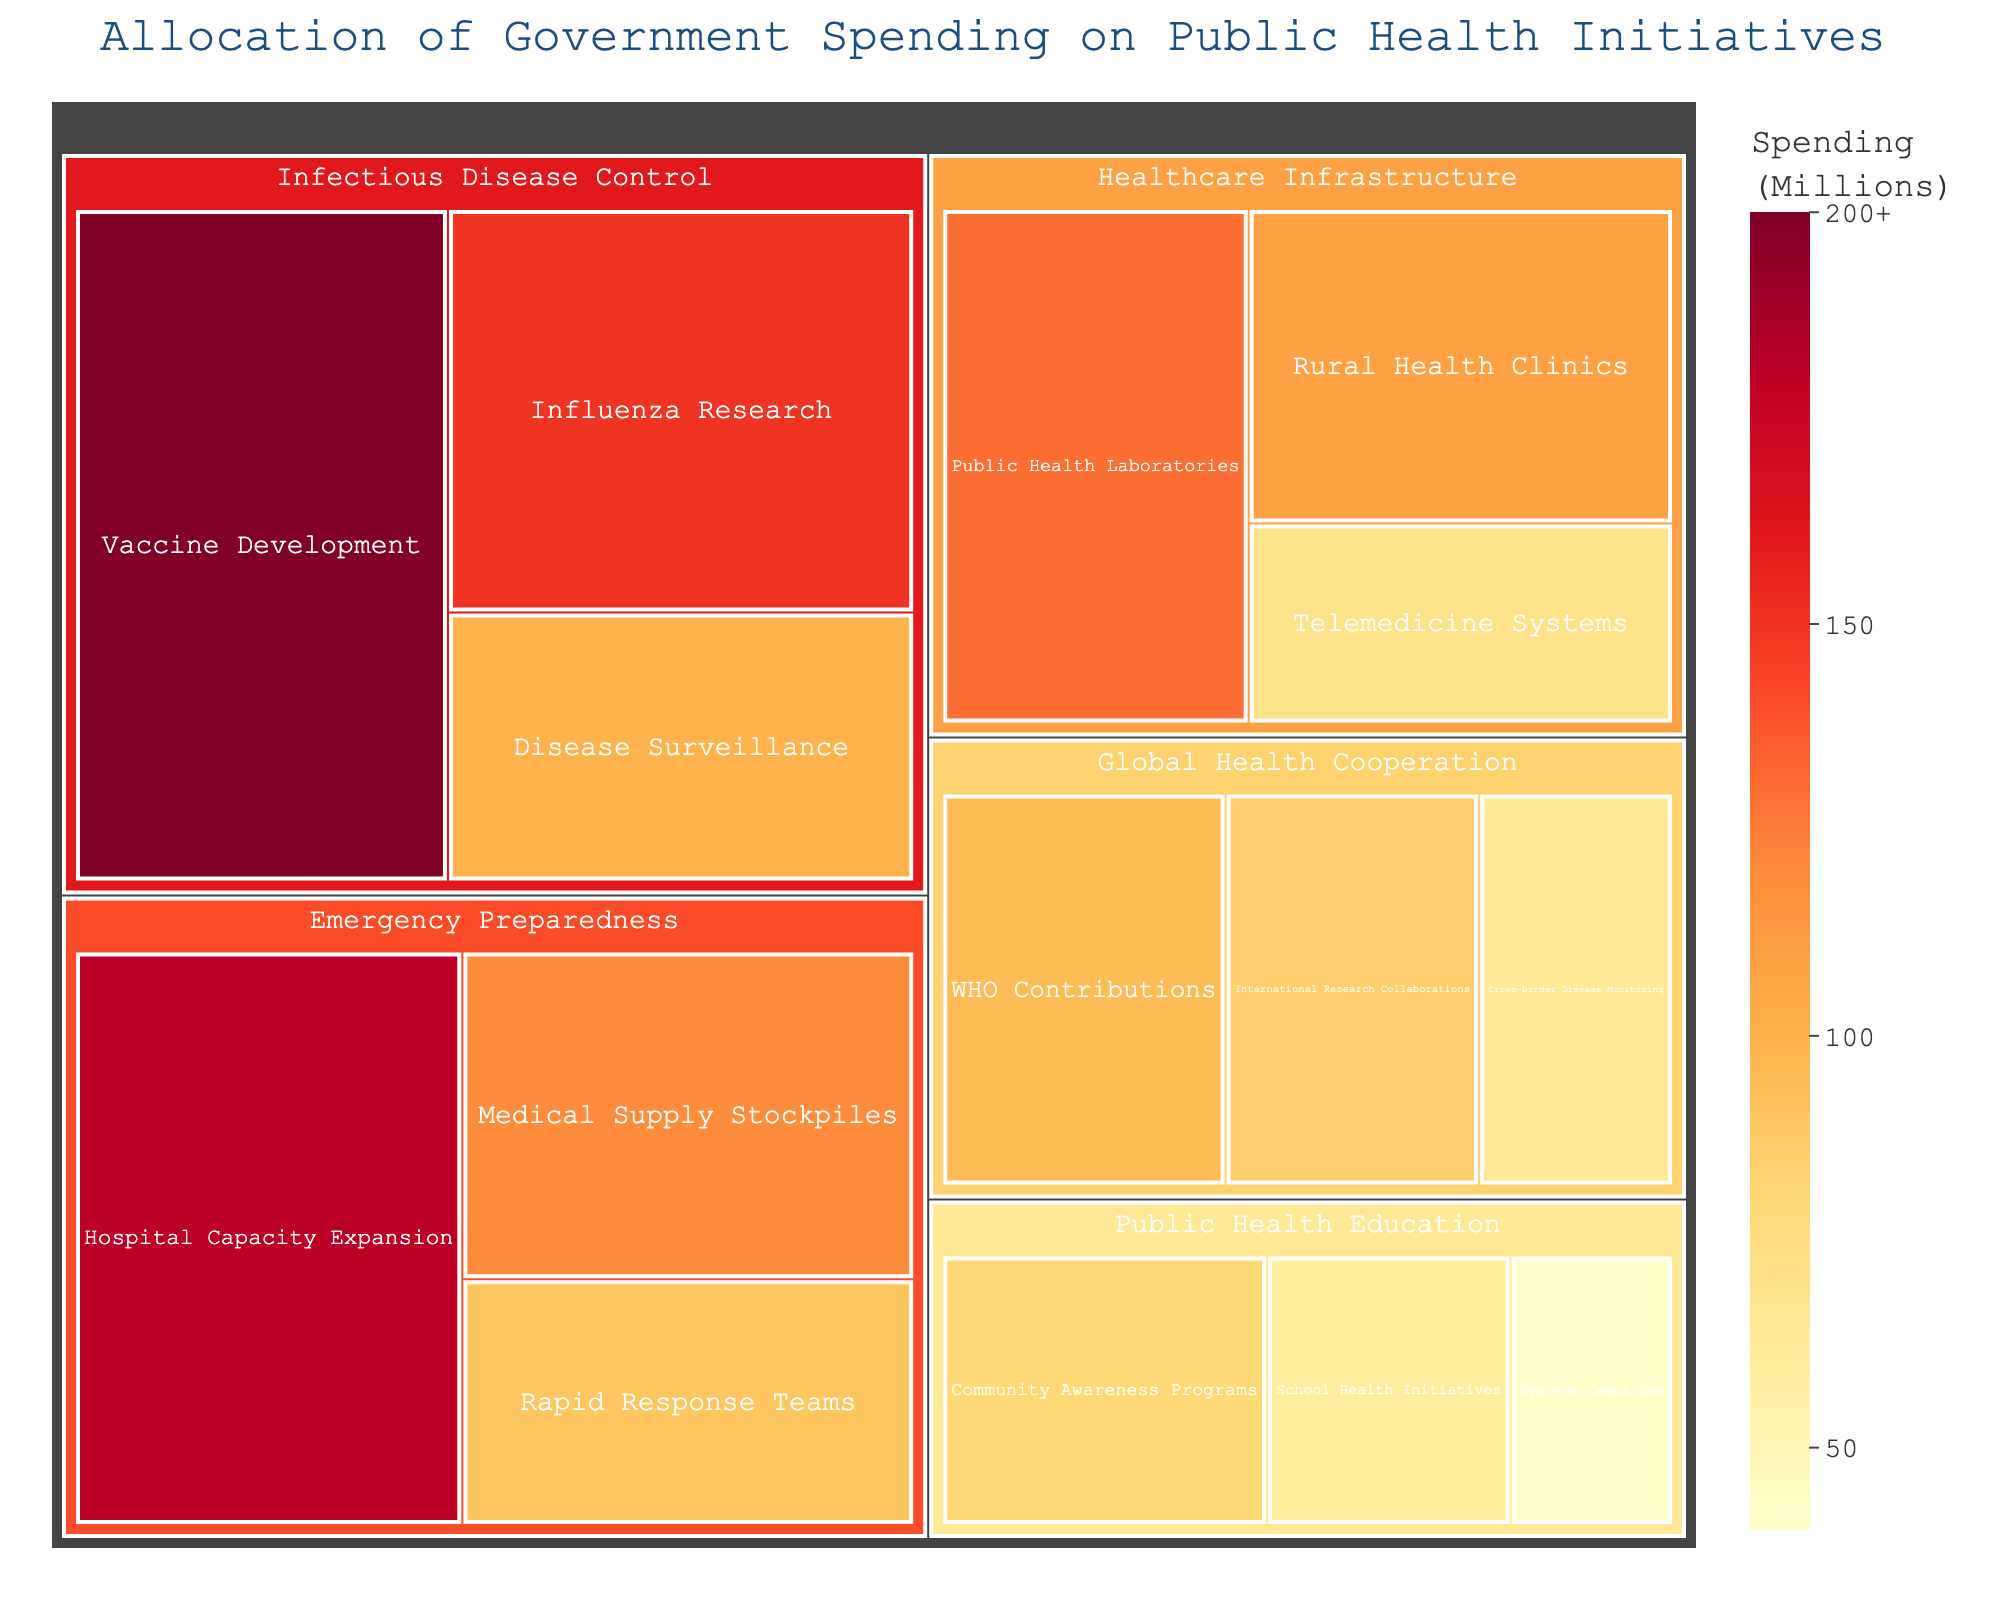How much does the government spend on Influenza Research? The treemap shows that the government spends $150 million on Influenza Research, indicated by the size of its box within the Infectious Disease Control category.
Answer: $150 million Which category receives the highest funding overall? By comparing the sizes of the boxes, it's clear that Infectious Disease Control has the largest total area, indicating it receives the highest funding.
Answer: Infectious Disease Control In Emergency Preparedness, which subcategory receives the least funding? Within the Emergency Preparedness category, the Rapid Response Teams subcategory has the smallest box, meaning it receives the least funding.
Answer: Rapid Response Teams Which has a higher budget: Public Health Laboratories or WHO Contributions? Comparing their boxes' sizes and colors, Public Health Laboratories ($130 million) has a higher budget than WHO Contributions ($95 million).
Answer: Public Health Laboratories What are the total funds allocated to Public Health Education? Summing the numbers for Community Awareness Programs ($80 million), School Health Initiatives ($60 million), and Hygiene Campaigns ($40 million), the total is $80 + $60 + $40 = $180 million.
Answer: $180 million What's the difference in spending between Hospital Capacity Expansion and Medical Supply Stockpiles? The spending difference between Hospital Capacity Expansion ($180 million) and Medical Supply Stockpiles ($120 million) is 180 - 120 = $60 million.
Answer: $60 million Is the spending on Vaccine Development higher than the combined spending on Rural Health Clinics and Telemedicine Systems? Summing Rural Health Clinics ($110 million) and Telemedicine Systems ($70 million) gives $110 + $70 = $180 million. Vaccine Development alone costs $200 million. Therefore, Vaccine Development spending is higher.
Answer: Yes How does spending on Cross-border Disease Monitoring compare to International Research Collaborations? Cross-border Disease Monitoring receives $65 million, while International Research Collaborations receive $85 million, making the latter higher.
Answer: International Research Collaborations What percentage of the spending on Emergency Preparedness is allocated to Hospital Capacity Expansion? The total spending on Emergency Preparedness is $180 + $120 + $90 = $390 million. The percentage for Hospital Capacity Expansion is ($180 million / $390 million) * 100 = approximately 46.15%.
Answer: 46.15% Which two categories have the closest funding amounts overall? Comparing the total funding of Healthcare Infrastructure and Global Health Cooperation shows that Healthcare Infrastructure ($110 + $70 + $130 = $310 million) and Global Health Cooperation ($95 + $85 + $65 = $245 million) have close funding amounts, with Healthcare Infrastructure being slightly higher. Among other categories, these two are the nearest in total funding.
Answer: Healthcare Infrastructure and Global Health Cooperation 